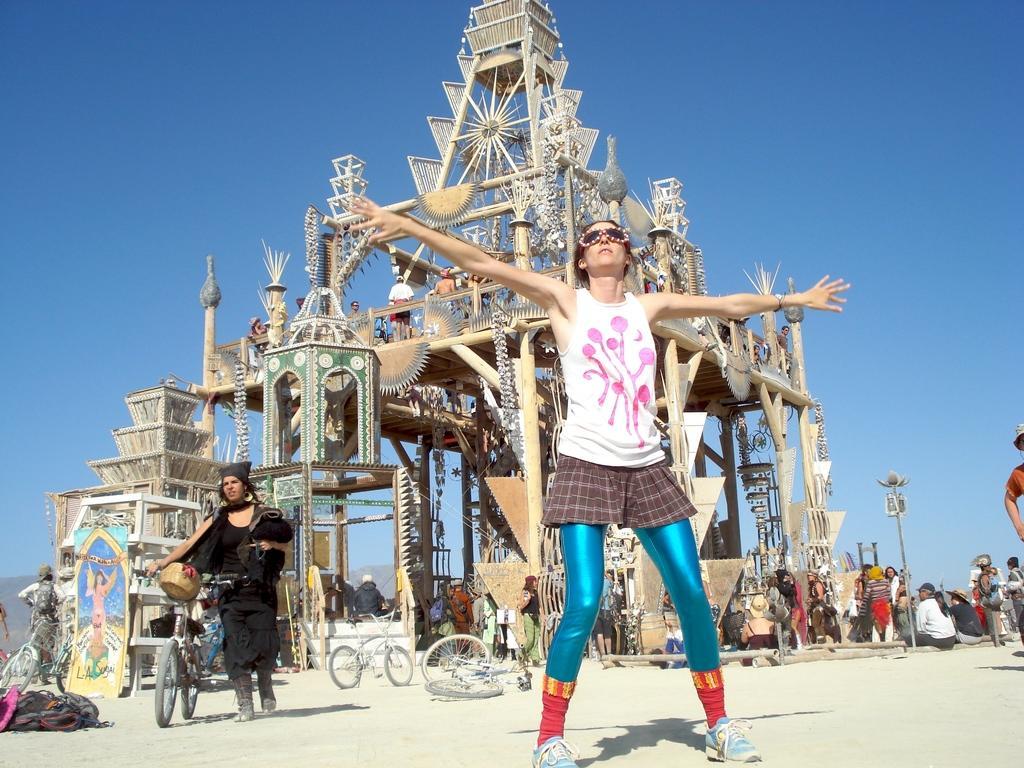How would you summarize this image in a sentence or two? In this picture we can see a group of people where some are standing and some are sitting on the ground, bicycles, bags, pole, architecture, poster and some objects and in the background we can see the sky. 